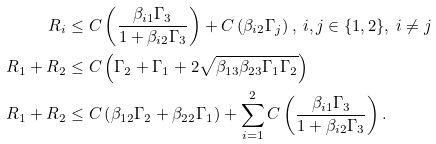Convert formula to latex. <formula><loc_0><loc_0><loc_500><loc_500>R _ { i } & \leq C \left ( \frac { \beta _ { i 1 } \Gamma _ { 3 } } { 1 + \beta _ { i 2 } \Gamma _ { 3 } } \right ) + C \left ( \beta _ { i 2 } \Gamma _ { j } \right ) , \ i , j \in \{ 1 , 2 \} , \ i \neq j \\ R _ { 1 } + R _ { 2 } & \leq C \left ( \Gamma _ { 2 } + \Gamma _ { 1 } + 2 \sqrt { \beta _ { 1 3 } \beta _ { 2 3 } \Gamma _ { 1 } \Gamma _ { 2 } } \right ) \\ R _ { 1 } + R _ { 2 } & \leq C \left ( \beta _ { 1 2 } \Gamma _ { 2 } + \beta _ { 2 2 } \Gamma _ { 1 } \right ) + \sum _ { i = 1 } ^ { 2 } C \left ( \frac { \beta _ { i 1 } \Gamma _ { 3 } } { 1 + \beta _ { i 2 } \Gamma _ { 3 } } \right ) .</formula> 